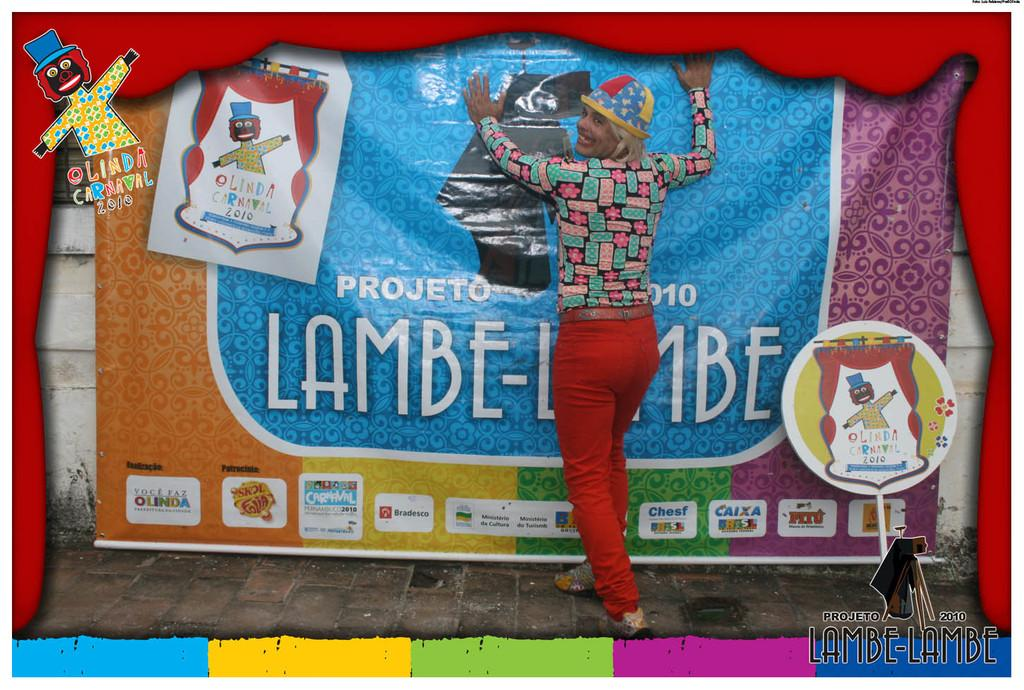Who or what is in the image? There is a person in the image. What is the person doing in the image? The person is standing by a poster and has their hands on the poster. What can be seen around the picture in the image? There is a colorful frame design around the picture. How many trucks are visible on the island in the image? There is no island or truck present in the image; it features a person standing by a poster with a colorful frame design. 